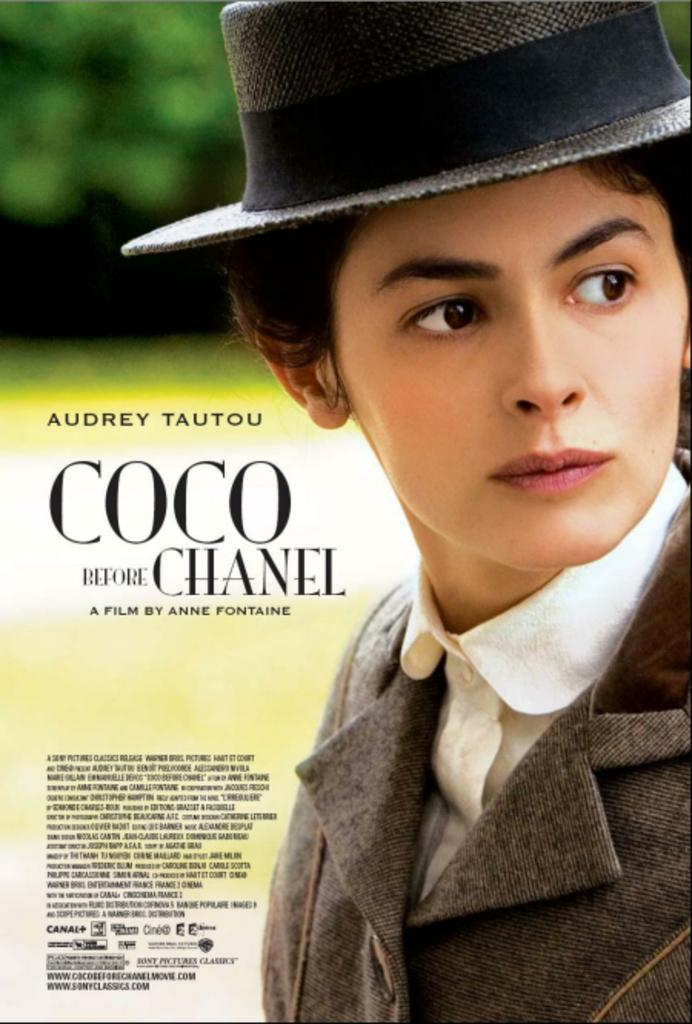What is present in the image that features a person? There is a poster in the image that features a person. What is the person on the poster wearing on their upper body? The person on the poster is wearing a jacket. What type of headwear is the person on the poster wearing? The person on the poster is wearing a hat. Are there any fairies visible on the poster in the image? No, there are no fairies present on the poster in the image. How many visitors can be seen interacting with the person on the poster? There are no visitors visible in the image; it only features the poster with the person on it. 